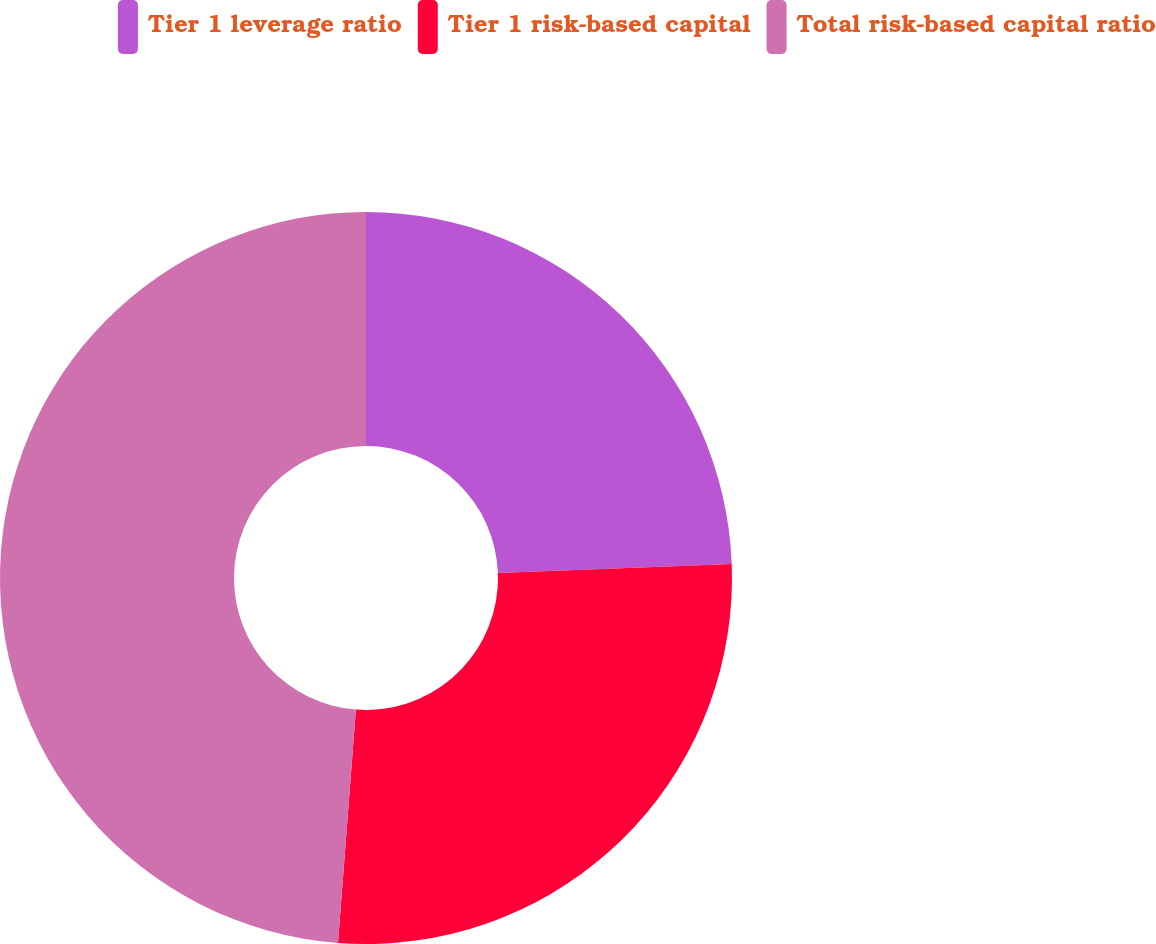<chart> <loc_0><loc_0><loc_500><loc_500><pie_chart><fcel>Tier 1 leverage ratio<fcel>Tier 1 risk-based capital<fcel>Total risk-based capital ratio<nl><fcel>24.39%<fcel>26.83%<fcel>48.78%<nl></chart> 